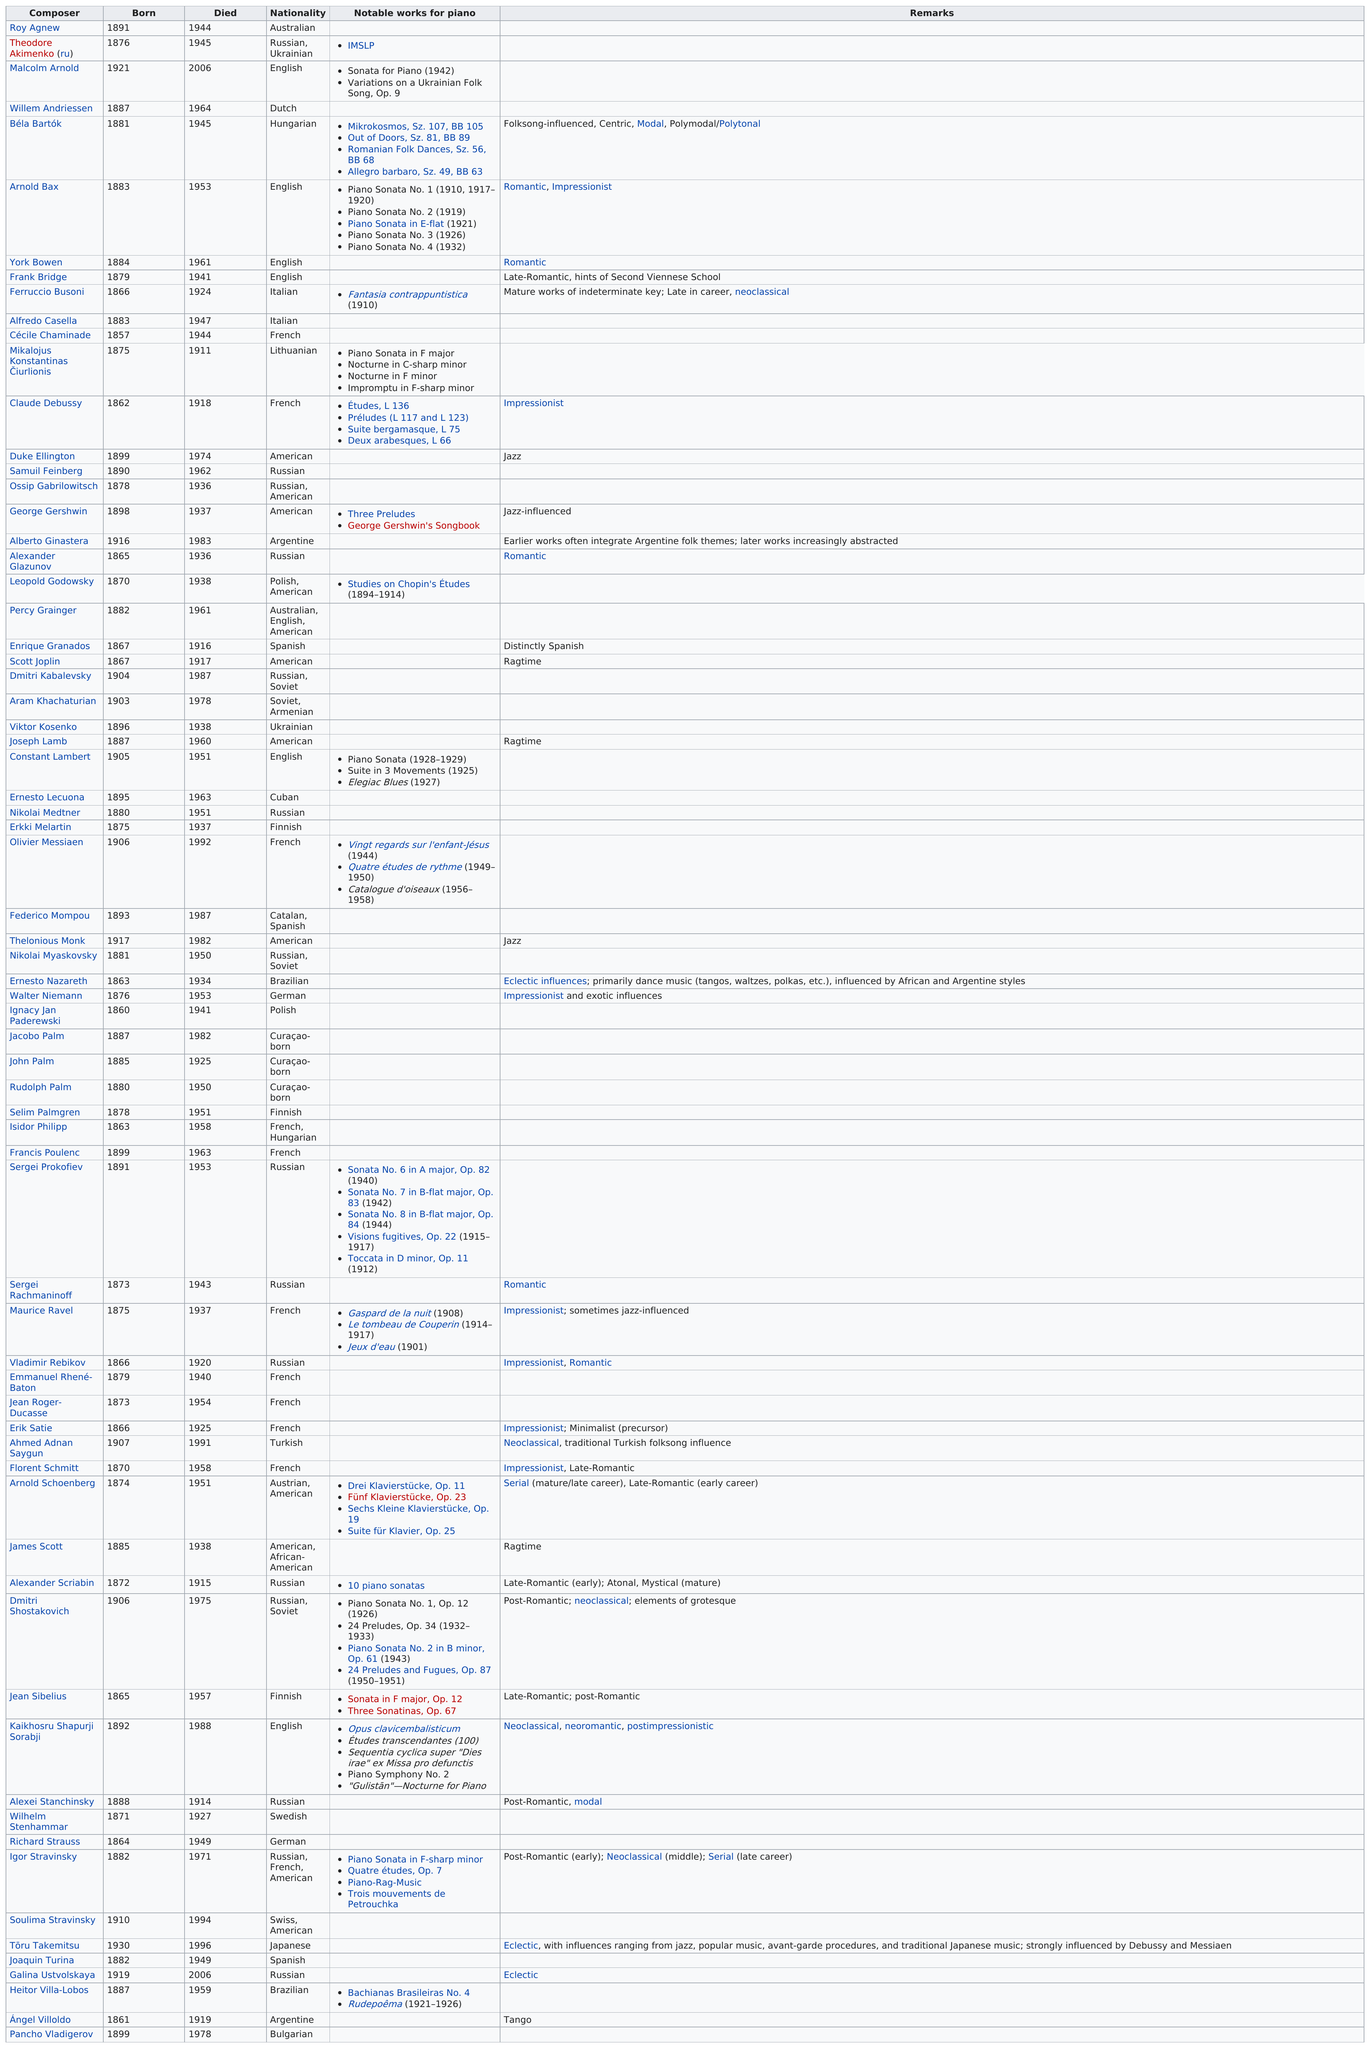Specify some key components in this picture. There were more than four American composers listed. I request that you provide the number of French individuals on the list. The number of composers who died before 1960 is 46. At the time of his death, Alberto Ginastera was 67 years old. How many pianists completed at least two notable works? 16 pianists completed at least two notable works. 